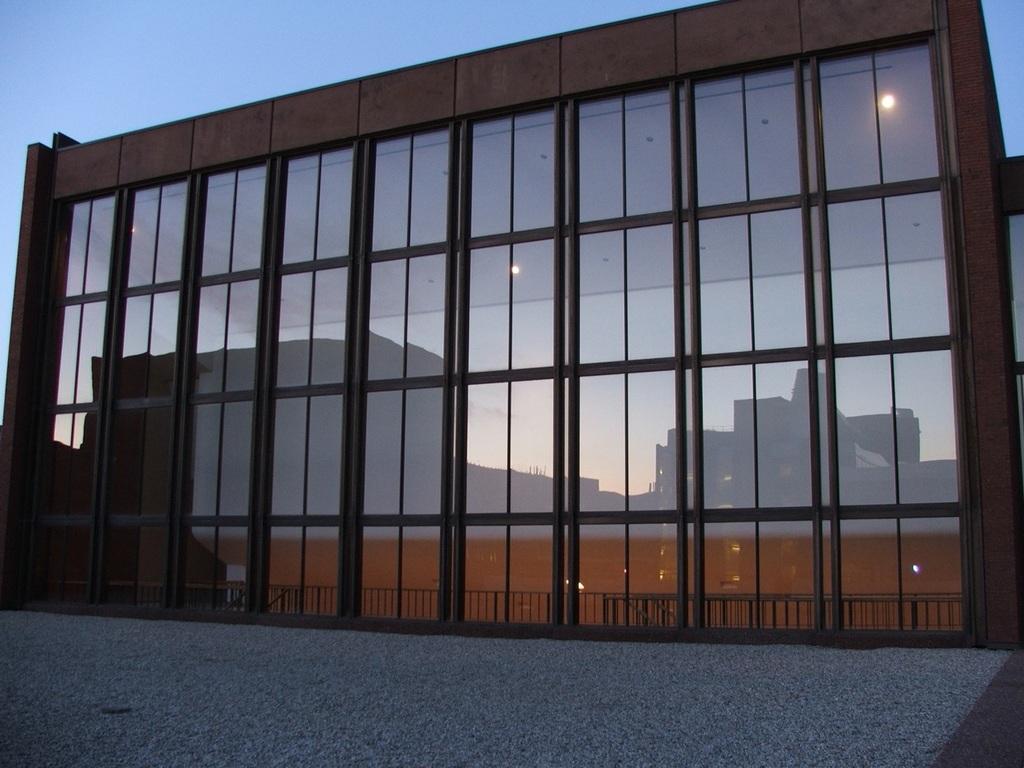Could you give a brief overview of what you see in this image? In this image we can see a building, glasses, floor and the sky. 